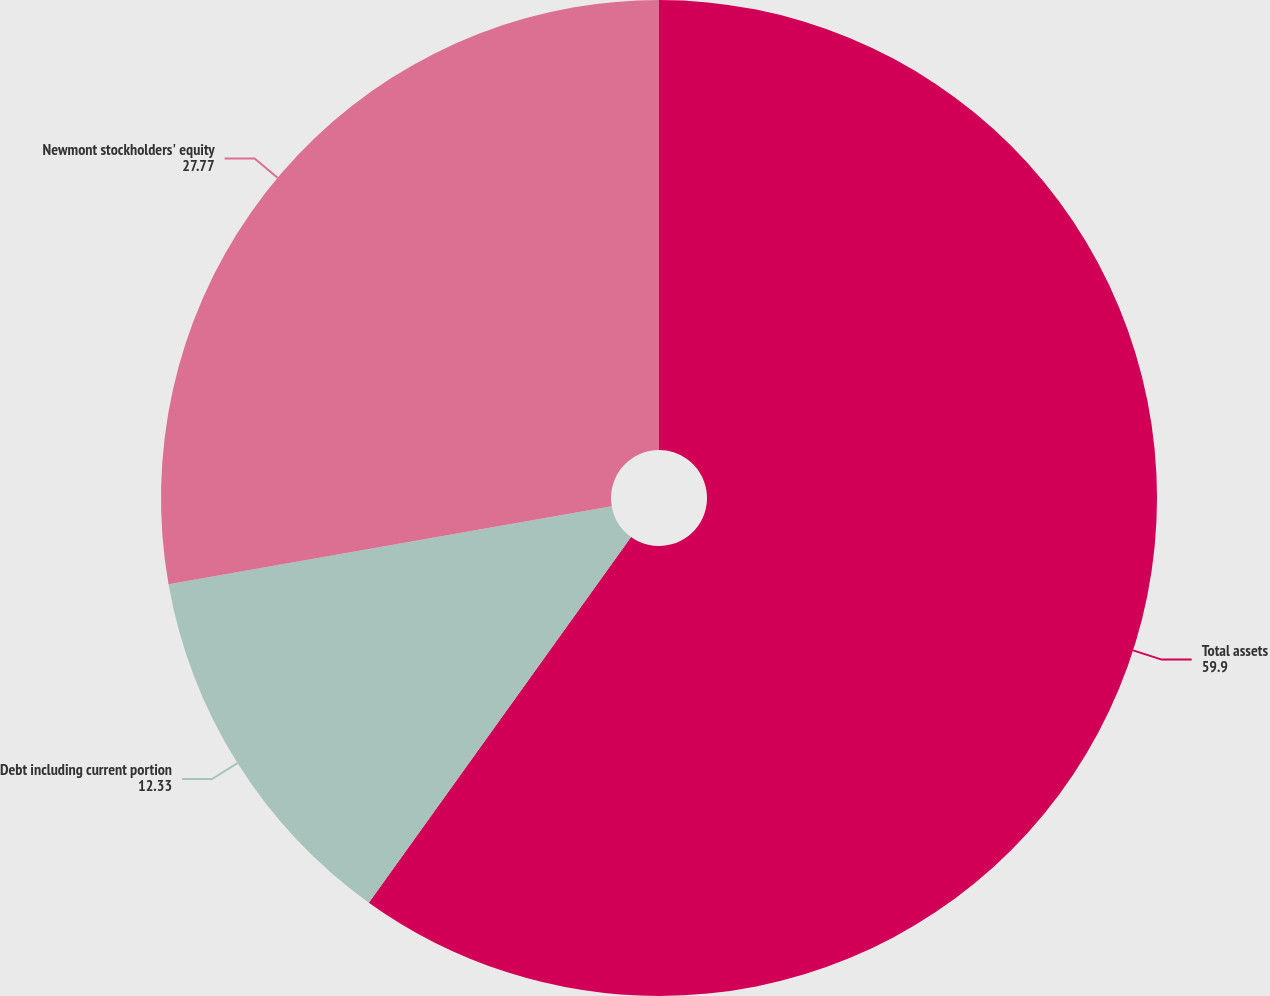Convert chart to OTSL. <chart><loc_0><loc_0><loc_500><loc_500><pie_chart><fcel>Total assets<fcel>Debt including current portion<fcel>Newmont stockholders' equity<nl><fcel>59.9%<fcel>12.33%<fcel>27.77%<nl></chart> 